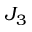Convert formula to latex. <formula><loc_0><loc_0><loc_500><loc_500>J _ { 3 }</formula> 